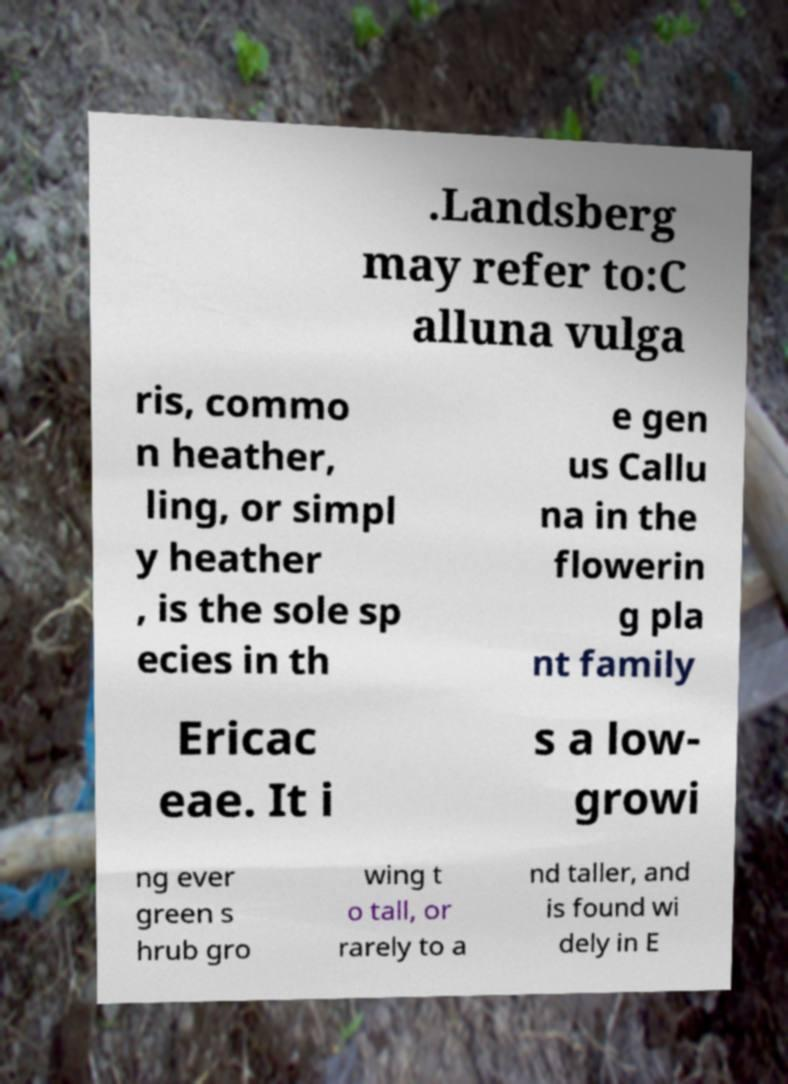I need the written content from this picture converted into text. Can you do that? .Landsberg may refer to:C alluna vulga ris, commo n heather, ling, or simpl y heather , is the sole sp ecies in th e gen us Callu na in the flowerin g pla nt family Ericac eae. It i s a low- growi ng ever green s hrub gro wing t o tall, or rarely to a nd taller, and is found wi dely in E 